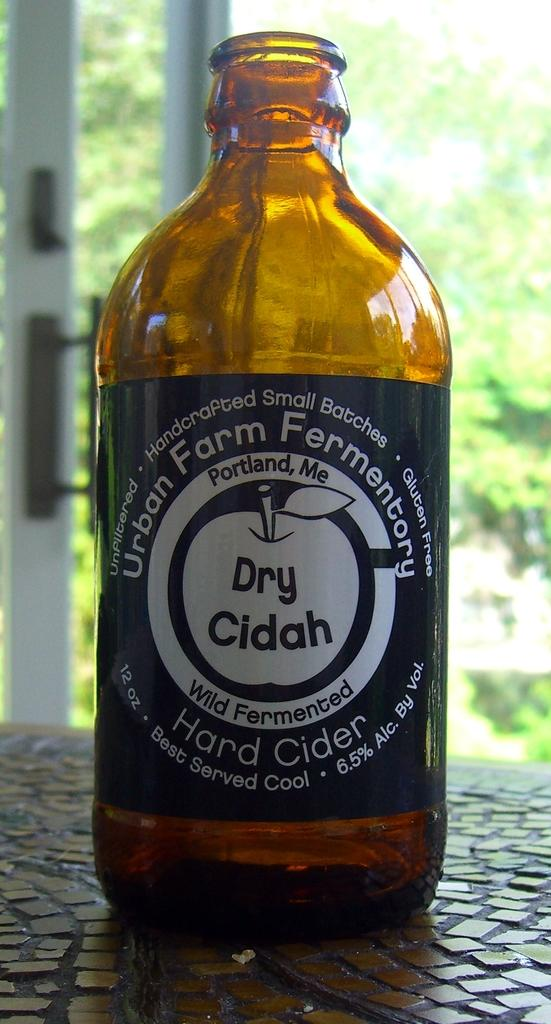<image>
Describe the image concisely. A bottle of hard cider from Urban Farm Fermentory in Portland, ME 